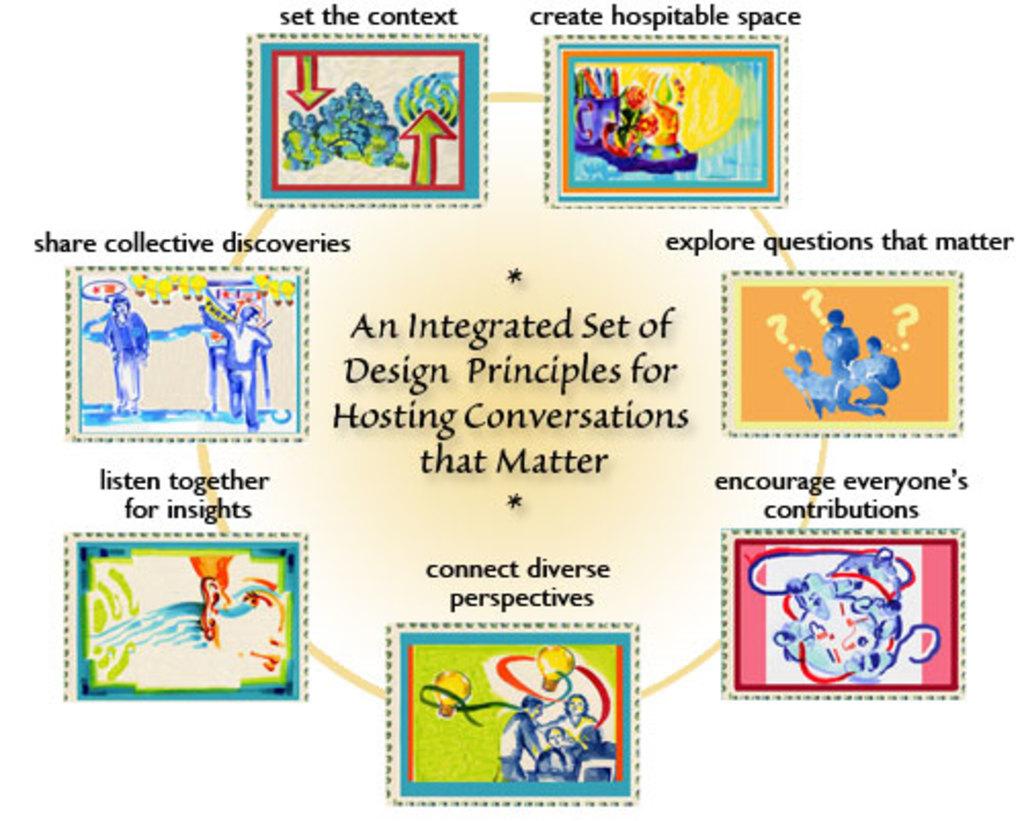What are these principles for?
Make the answer very short. Hosting conversations that matter. Whose contribution should be encouraged?
Provide a short and direct response. Everyone's. 